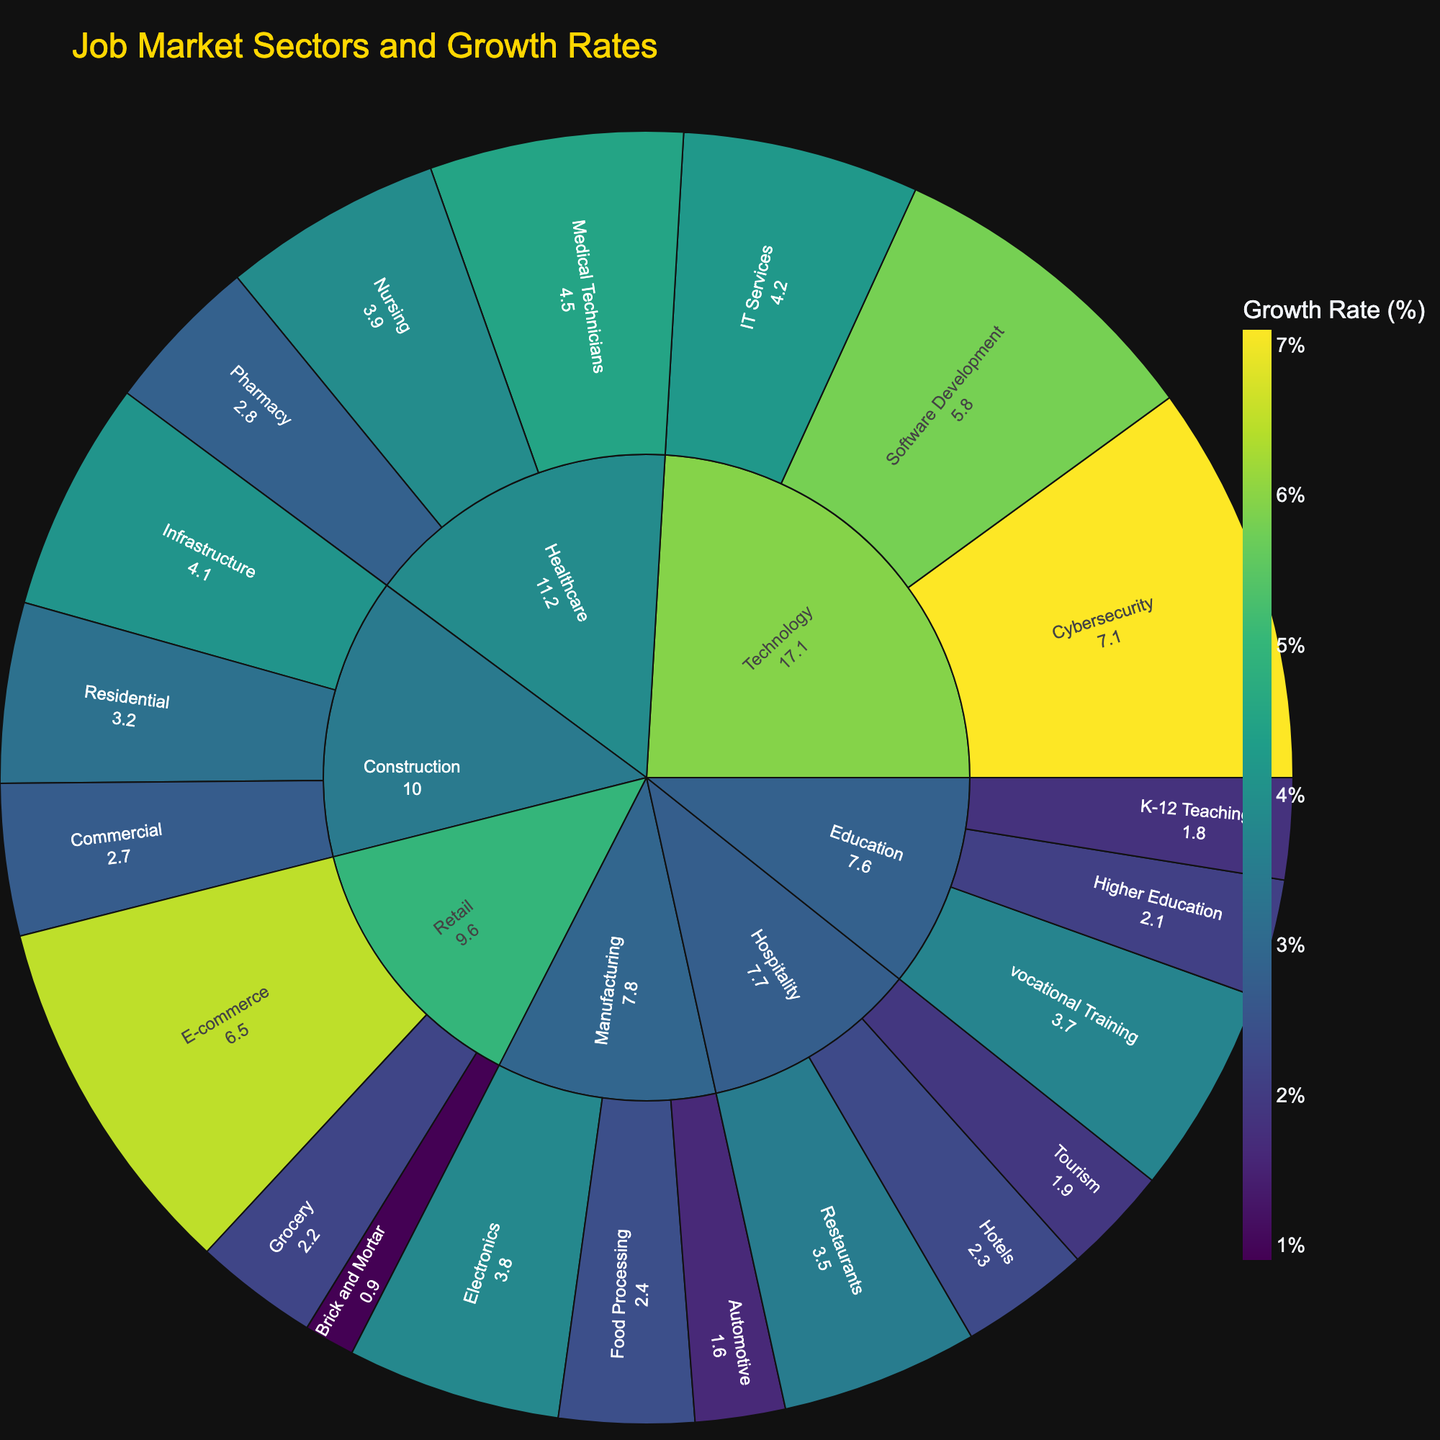what is the title of the sunburst plot? The title of a plot is generally found at the top of the figure. In this case, the title is given in the code snippet: "Job Market Sectors and Growth Rates".
Answer: Job Market Sectors and Growth Rates Which sector has the highest growth rate in one of its subsectors? By examining the sunburst plot, we look for the sector whose subsector has the highest growth rate. In this case, the Technology sector has a subsector, Cybersecurity, with the highest growth rate of 7.1%.
Answer: Technology Which subsector in Retail has the highest growth rate? Within the Retail sector, we identify that E-commerce has the highest growth rate. The growth rates for subsectors in Retail are Brick and Mortar (0.9), Grocery (2.2), and E-commerce (6.5).
Answer: E-commerce What are the subsectors within the Construction sector? By examining the sunburst plot, we see that the Construction sector includes the following subsectors: Residential, Commercial, and Infrastructure.
Answer: Residential, Commercial, Infrastructure How does the growth rate of Software Development compare with that of Cybersecurity? Both Software Development and Cybersecurity are within the Technology sector. The growth rate of Software Development is 5.8%, and Cybersecurity is 7.1%. Hence, Cybersecurity has a higher growth rate.
Answer: Cybersecurity has a higher growth rate What is the average growth rate of subsectors in the Healthcare sector? The subsectors in Healthcare are Nursing (3.9), Medical Technicians (4.5), and Pharmacy (2.8). Calculate the average: (3.9 + 4.5 + 2.8) / 3 = 3.73%.
Answer: 3.73% Compare the growth rates between the sectors of Hospitality and Manufacturing. Which has a higher overall growth rate in their subsectors? The subsectors for Hospitality are Hotels (2.3), Restaurants (3.5), and Tourism (1.9). For Manufacturing, they are Automotive (1.6), Electronics (3.8), and Food Processing (2.4). Adding them up: Hospitality (2.3 + 3.5 + 1.9) = 7.7; Manufacturing (1.6 + 3.8 + 2.4) = 7.8. Hence, Manufacturing has a slightly higher overall growth rate in their subsectors.
Answer: Manufacturing Which subsector in Technology has the lowest growth rate? In the Technology sector, the subsectors’ growth rates are Software Development (5.8), IT Services (4.2), and Cybersecurity (7.1). Hence, IT Services has the lowest growth rate.
Answer: IT Services How many subsectors are present in the Hospitality sector? We count the number of subsectors visible in the Hospitality sector. They are Hotels, Restaurants, and Tourism, making it 3 subsectors in total.
Answer: 3 Name all the sectors and their corresponding subsectors with a growth rate above 4%. By examining the plot, we identify the following: Technology (Software Development, Cybersecurity), Healthcare (Medical Technicians), and Retail (E-commerce).
Answer: Technology (Software Development, Cybersecurity), Healthcare (Medical Technicians), Retail (E-commerce) 